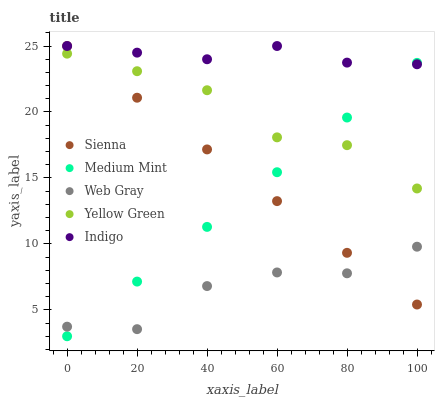Does Web Gray have the minimum area under the curve?
Answer yes or no. Yes. Does Indigo have the maximum area under the curve?
Answer yes or no. Yes. Does Medium Mint have the minimum area under the curve?
Answer yes or no. No. Does Medium Mint have the maximum area under the curve?
Answer yes or no. No. Is Medium Mint the smoothest?
Answer yes or no. Yes. Is Web Gray the roughest?
Answer yes or no. Yes. Is Web Gray the smoothest?
Answer yes or no. No. Is Medium Mint the roughest?
Answer yes or no. No. Does Medium Mint have the lowest value?
Answer yes or no. Yes. Does Web Gray have the lowest value?
Answer yes or no. No. Does Indigo have the highest value?
Answer yes or no. Yes. Does Medium Mint have the highest value?
Answer yes or no. No. Is Web Gray less than Yellow Green?
Answer yes or no. Yes. Is Yellow Green greater than Web Gray?
Answer yes or no. Yes. Does Web Gray intersect Sienna?
Answer yes or no. Yes. Is Web Gray less than Sienna?
Answer yes or no. No. Is Web Gray greater than Sienna?
Answer yes or no. No. Does Web Gray intersect Yellow Green?
Answer yes or no. No. 